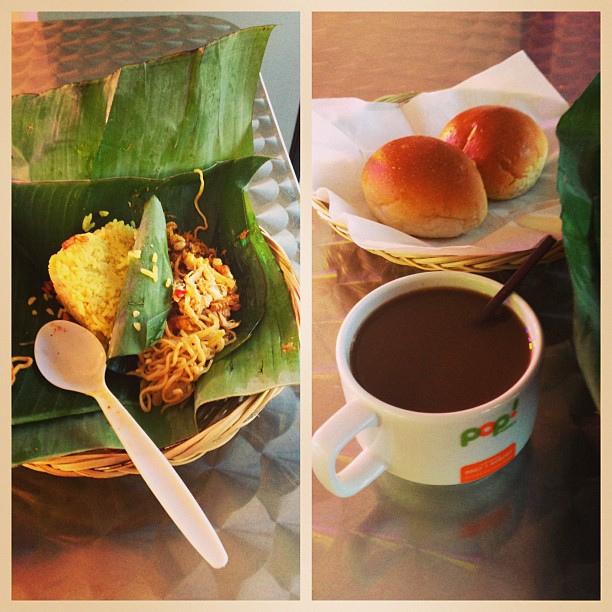How many rolls are in this photo?
Write a very short answer. 2. How many rolls are in this photo?
Keep it brief. 2. Are these food selfies?
Give a very brief answer. Yes. 